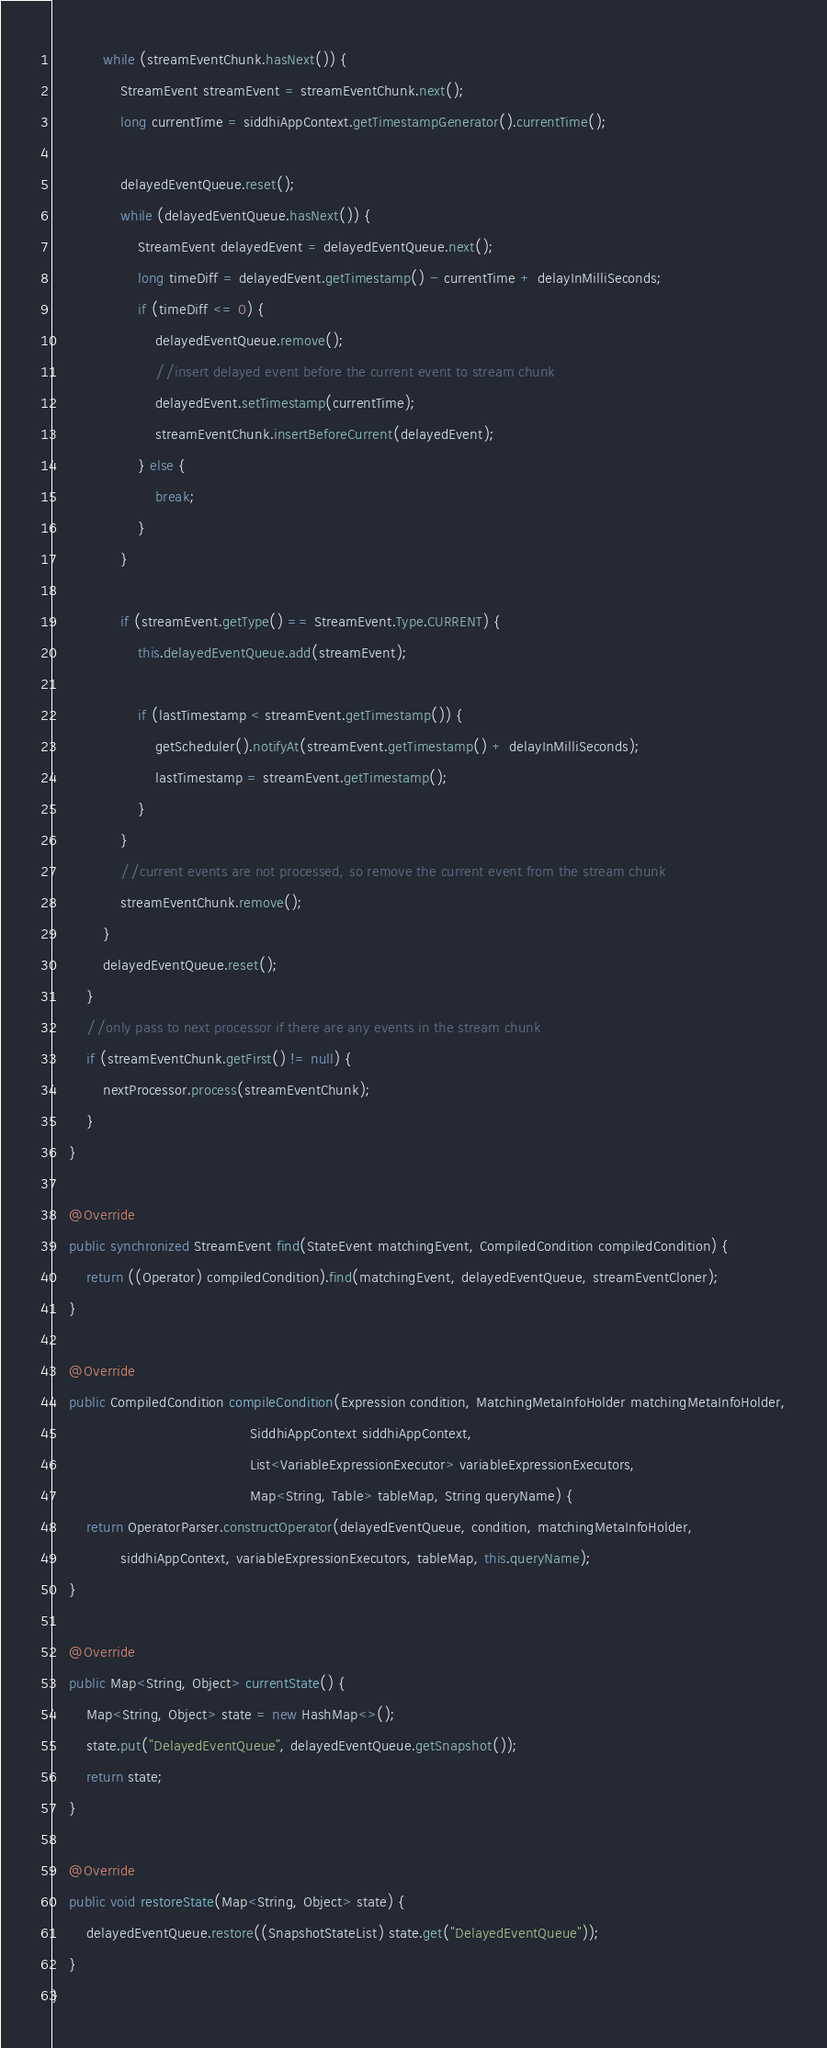<code> <loc_0><loc_0><loc_500><loc_500><_Java_>            while (streamEventChunk.hasNext()) {
                StreamEvent streamEvent = streamEventChunk.next();
                long currentTime = siddhiAppContext.getTimestampGenerator().currentTime();

                delayedEventQueue.reset();
                while (delayedEventQueue.hasNext()) {
                    StreamEvent delayedEvent = delayedEventQueue.next();
                    long timeDiff = delayedEvent.getTimestamp() - currentTime + delayInMilliSeconds;
                    if (timeDiff <= 0) {
                        delayedEventQueue.remove();
                        //insert delayed event before the current event to stream chunk
                        delayedEvent.setTimestamp(currentTime);
                        streamEventChunk.insertBeforeCurrent(delayedEvent);
                    } else {
                        break;
                    }
                }

                if (streamEvent.getType() == StreamEvent.Type.CURRENT) {
                    this.delayedEventQueue.add(streamEvent);

                    if (lastTimestamp < streamEvent.getTimestamp()) {
                        getScheduler().notifyAt(streamEvent.getTimestamp() + delayInMilliSeconds);
                        lastTimestamp = streamEvent.getTimestamp();
                    }
                }
                //current events are not processed, so remove the current event from the stream chunk
                streamEventChunk.remove();
            }
            delayedEventQueue.reset();
        }
        //only pass to next processor if there are any events in the stream chunk
        if (streamEventChunk.getFirst() != null) {
            nextProcessor.process(streamEventChunk);
        }
    }

    @Override
    public synchronized StreamEvent find(StateEvent matchingEvent, CompiledCondition compiledCondition) {
        return ((Operator) compiledCondition).find(matchingEvent, delayedEventQueue, streamEventCloner);
    }

    @Override
    public CompiledCondition compileCondition(Expression condition, MatchingMetaInfoHolder matchingMetaInfoHolder,
                                              SiddhiAppContext siddhiAppContext,
                                              List<VariableExpressionExecutor> variableExpressionExecutors,
                                              Map<String, Table> tableMap, String queryName) {
        return OperatorParser.constructOperator(delayedEventQueue, condition, matchingMetaInfoHolder,
                siddhiAppContext, variableExpressionExecutors, tableMap, this.queryName);
    }

    @Override
    public Map<String, Object> currentState() {
        Map<String, Object> state = new HashMap<>();
        state.put("DelayedEventQueue", delayedEventQueue.getSnapshot());
        return state;
    }

    @Override
    public void restoreState(Map<String, Object> state) {
        delayedEventQueue.restore((SnapshotStateList) state.get("DelayedEventQueue"));
    }
}
</code> 